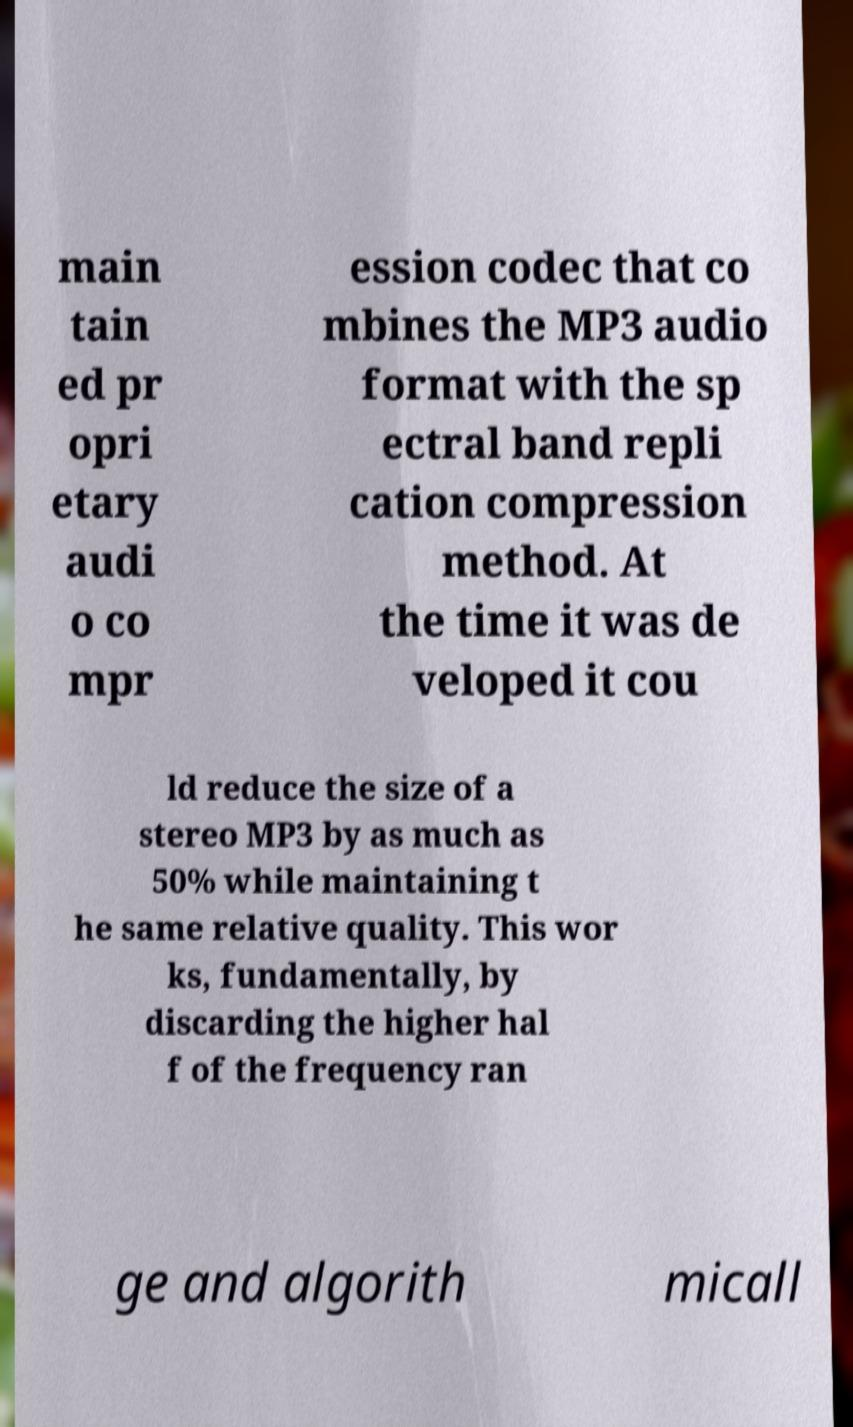For documentation purposes, I need the text within this image transcribed. Could you provide that? main tain ed pr opri etary audi o co mpr ession codec that co mbines the MP3 audio format with the sp ectral band repli cation compression method. At the time it was de veloped it cou ld reduce the size of a stereo MP3 by as much as 50% while maintaining t he same relative quality. This wor ks, fundamentally, by discarding the higher hal f of the frequency ran ge and algorith micall 